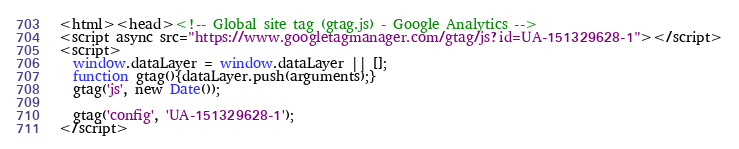Convert code to text. <code><loc_0><loc_0><loc_500><loc_500><_HTML_><html><head><!-- Global site tag (gtag.js) - Google Analytics -->
<script async src="https://www.googletagmanager.com/gtag/js?id=UA-151329628-1"></script>
<script>
  window.dataLayer = window.dataLayer || [];
  function gtag(){dataLayer.push(arguments);}
  gtag('js', new Date());

  gtag('config', 'UA-151329628-1');
</script></code> 